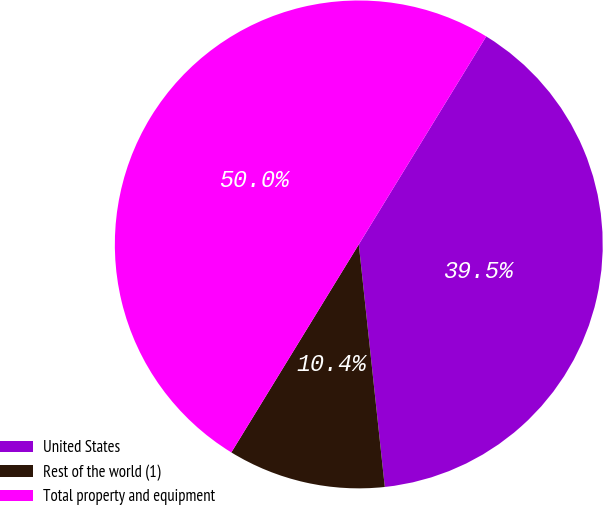Convert chart to OTSL. <chart><loc_0><loc_0><loc_500><loc_500><pie_chart><fcel>United States<fcel>Rest of the world (1)<fcel>Total property and equipment<nl><fcel>39.55%<fcel>10.45%<fcel>50.0%<nl></chart> 